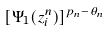<formula> <loc_0><loc_0><loc_500><loc_500>[ \Psi _ { 1 } ( z _ { i } ^ { n } ) ] ^ { p _ { n } - \theta _ { n } }</formula> 